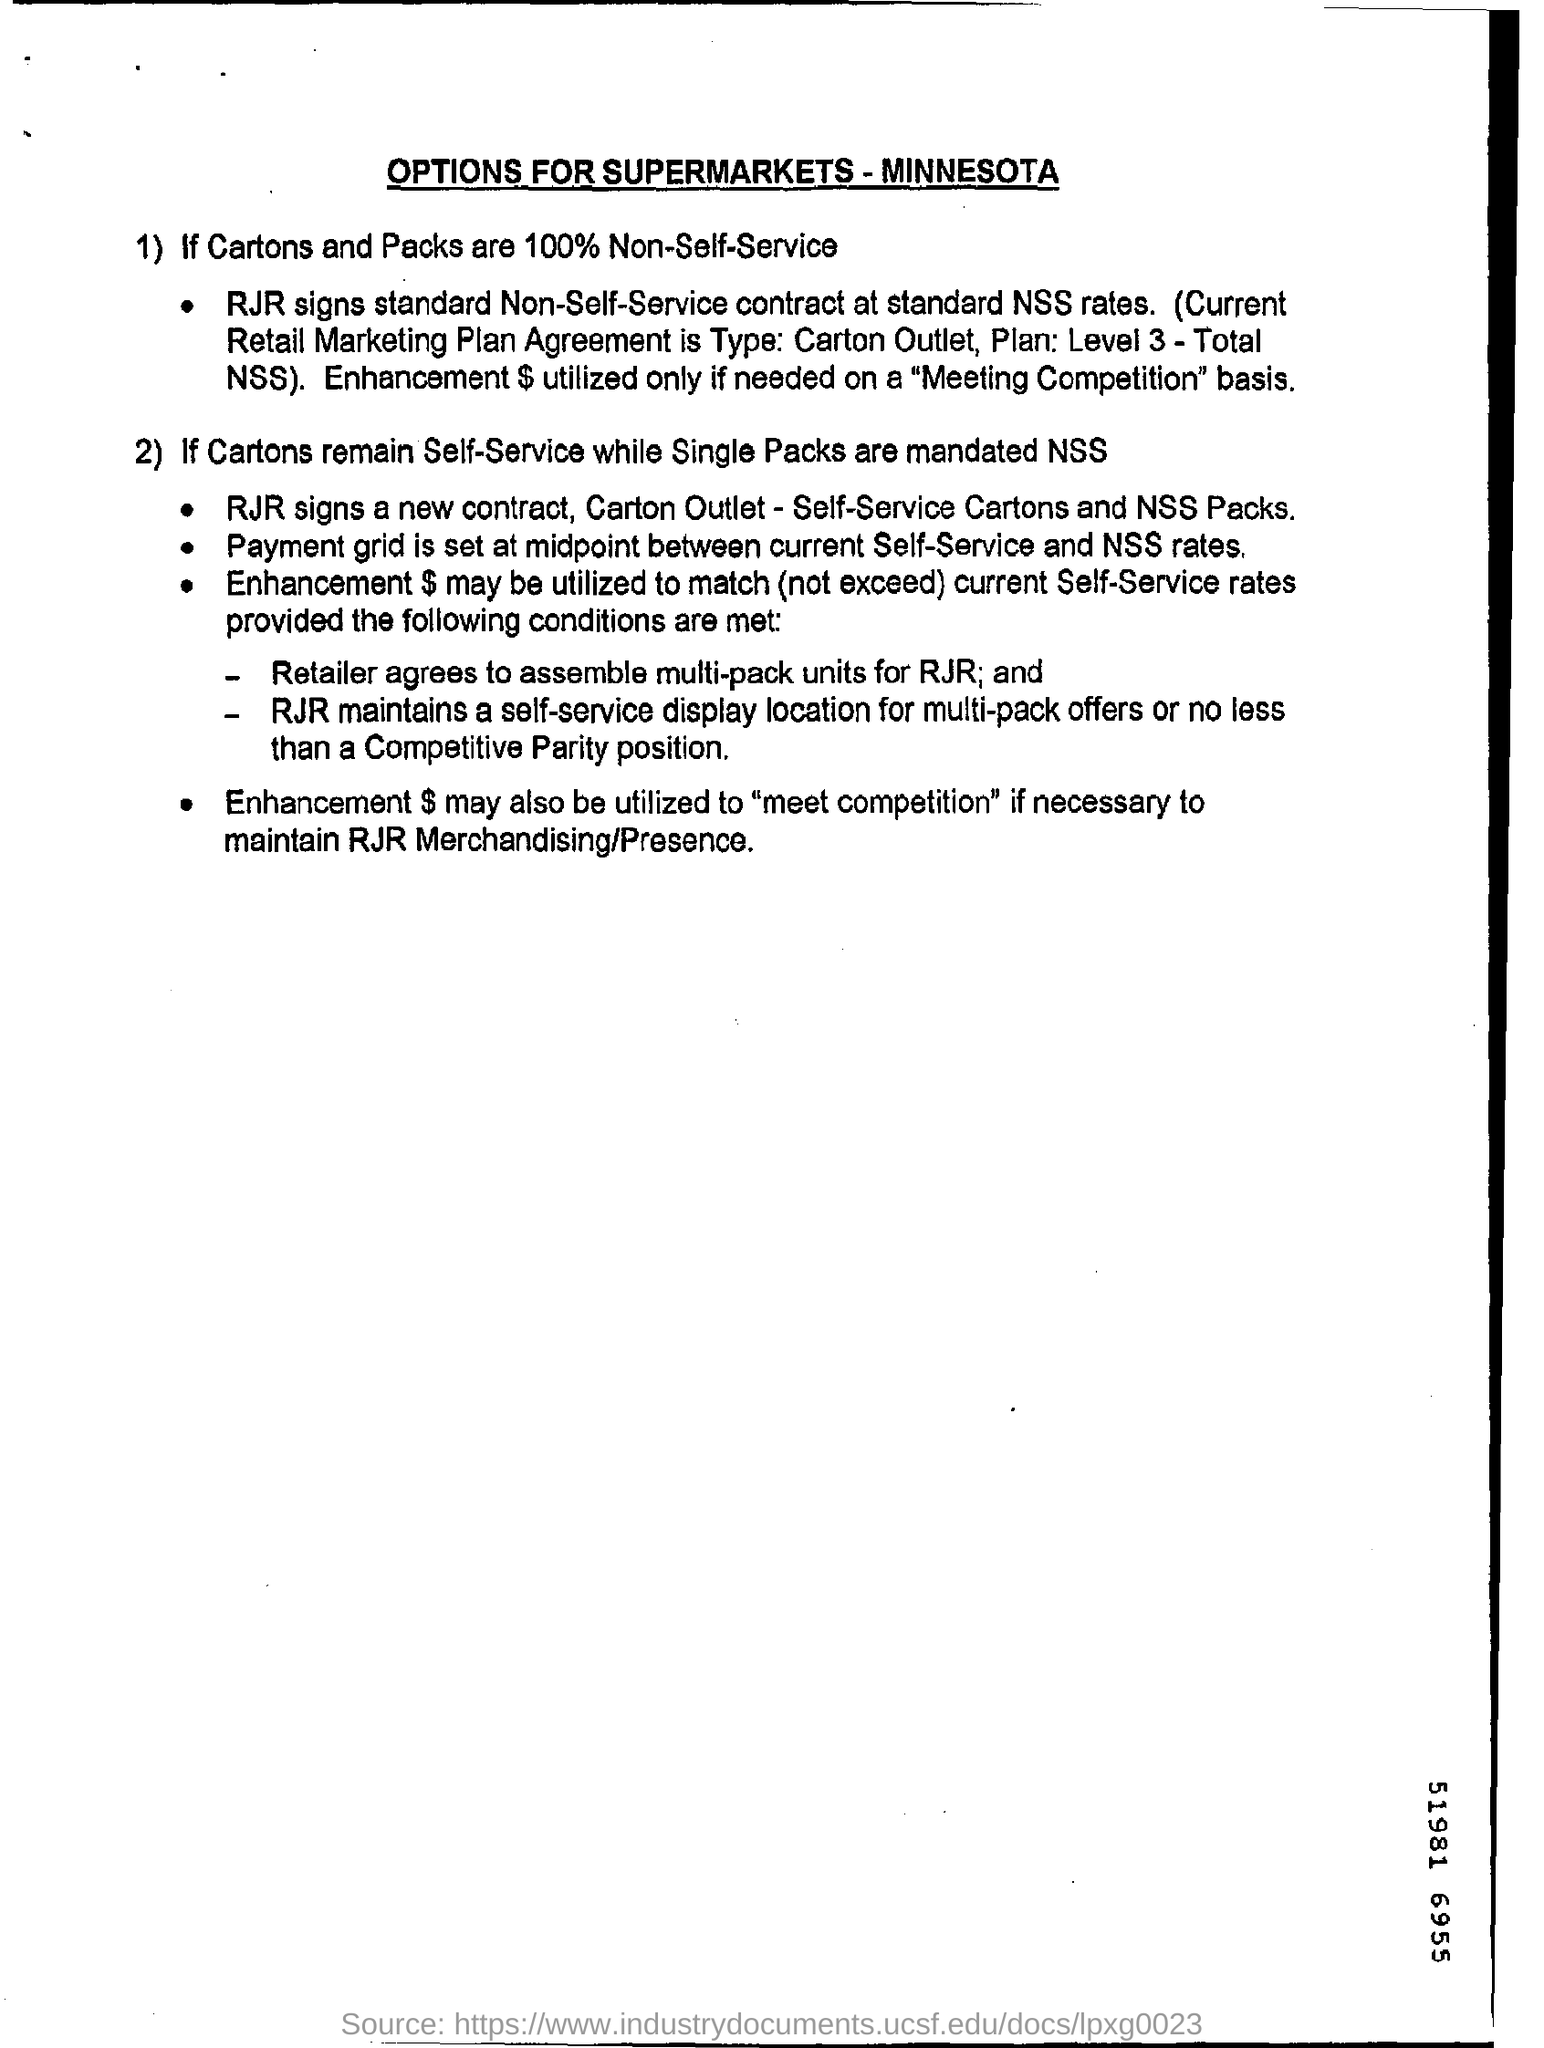Highlight a few significant elements in this photo. The headline of this document pertains to options for supermarkets in the state of Minnesota. The level of Plan 3 is currently at 3. The retailer is responsible for assembling multi-pack units. 